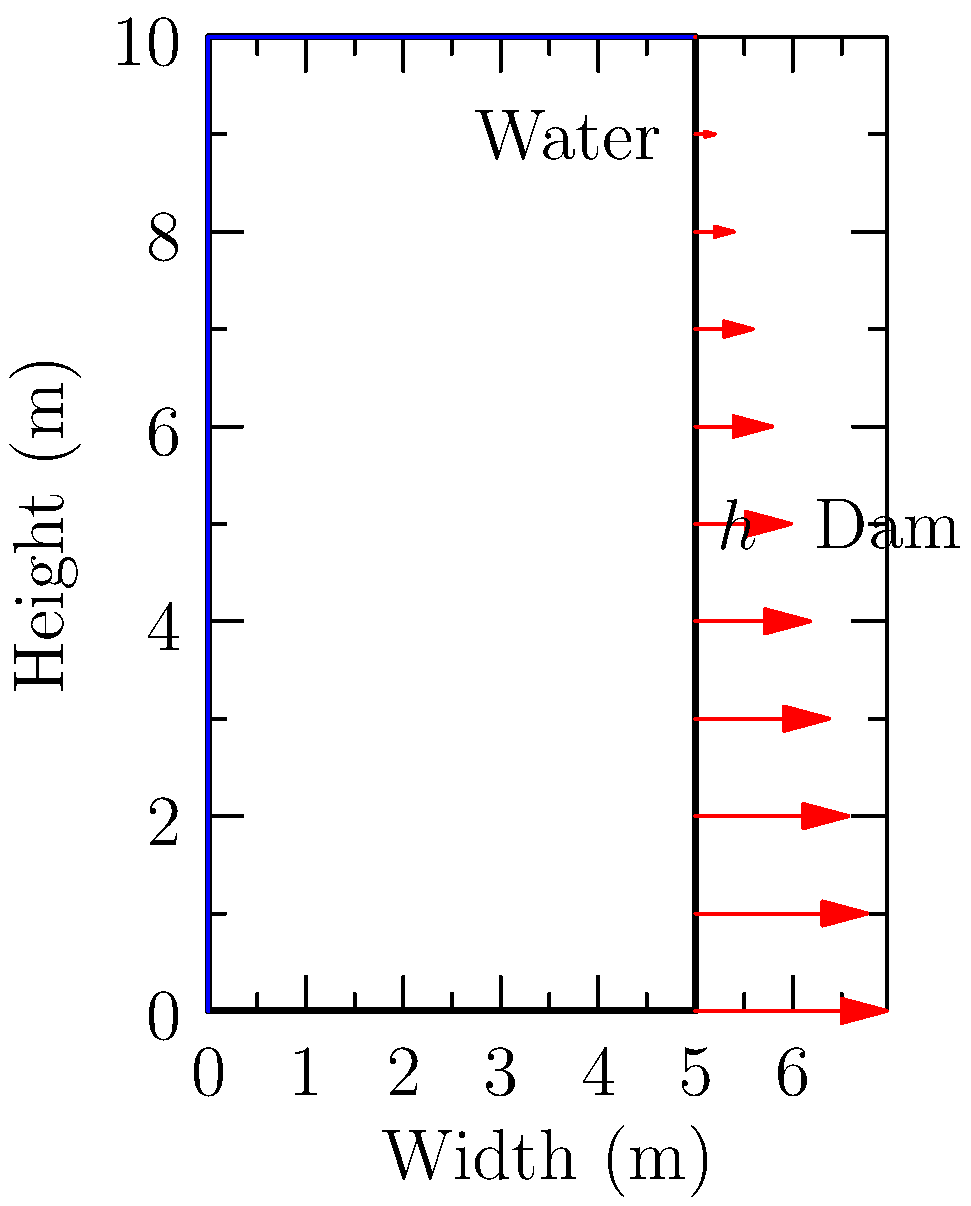As a graphic designer creating an animated feature for a civil engineering Superfan blog, you need to visualize the water pressure distribution on a dam wall. Given a dam of height $h=10$ m and water with a specific weight of $\gamma=9.81$ kN/m³, what is the maximum water pressure (in kPa) at the base of the dam? To determine the maximum water pressure at the base of the dam, we can follow these steps:

1. Understand the pressure distribution:
   - Water pressure increases linearly with depth
   - Maximum pressure occurs at the base of the dam

2. Use the hydrostatic pressure equation:
   $P = \gamma h$
   Where:
   $P$ = pressure (kPa)
   $\gamma$ = specific weight of water (kN/m³)
   $h$ = depth of water (m)

3. Input the given values:
   $\gamma = 9.81$ kN/m³
   $h = 10$ m

4. Calculate the maximum pressure:
   $P = 9.81 \text{ kN/m³} \times 10 \text{ m}$
   $P = 98.1$ kN/m²

5. Convert kN/m² to kPa:
   $98.1$ kN/m² = $98.1$ kPa

Therefore, the maximum water pressure at the base of the dam is 98.1 kPa.
Answer: 98.1 kPa 